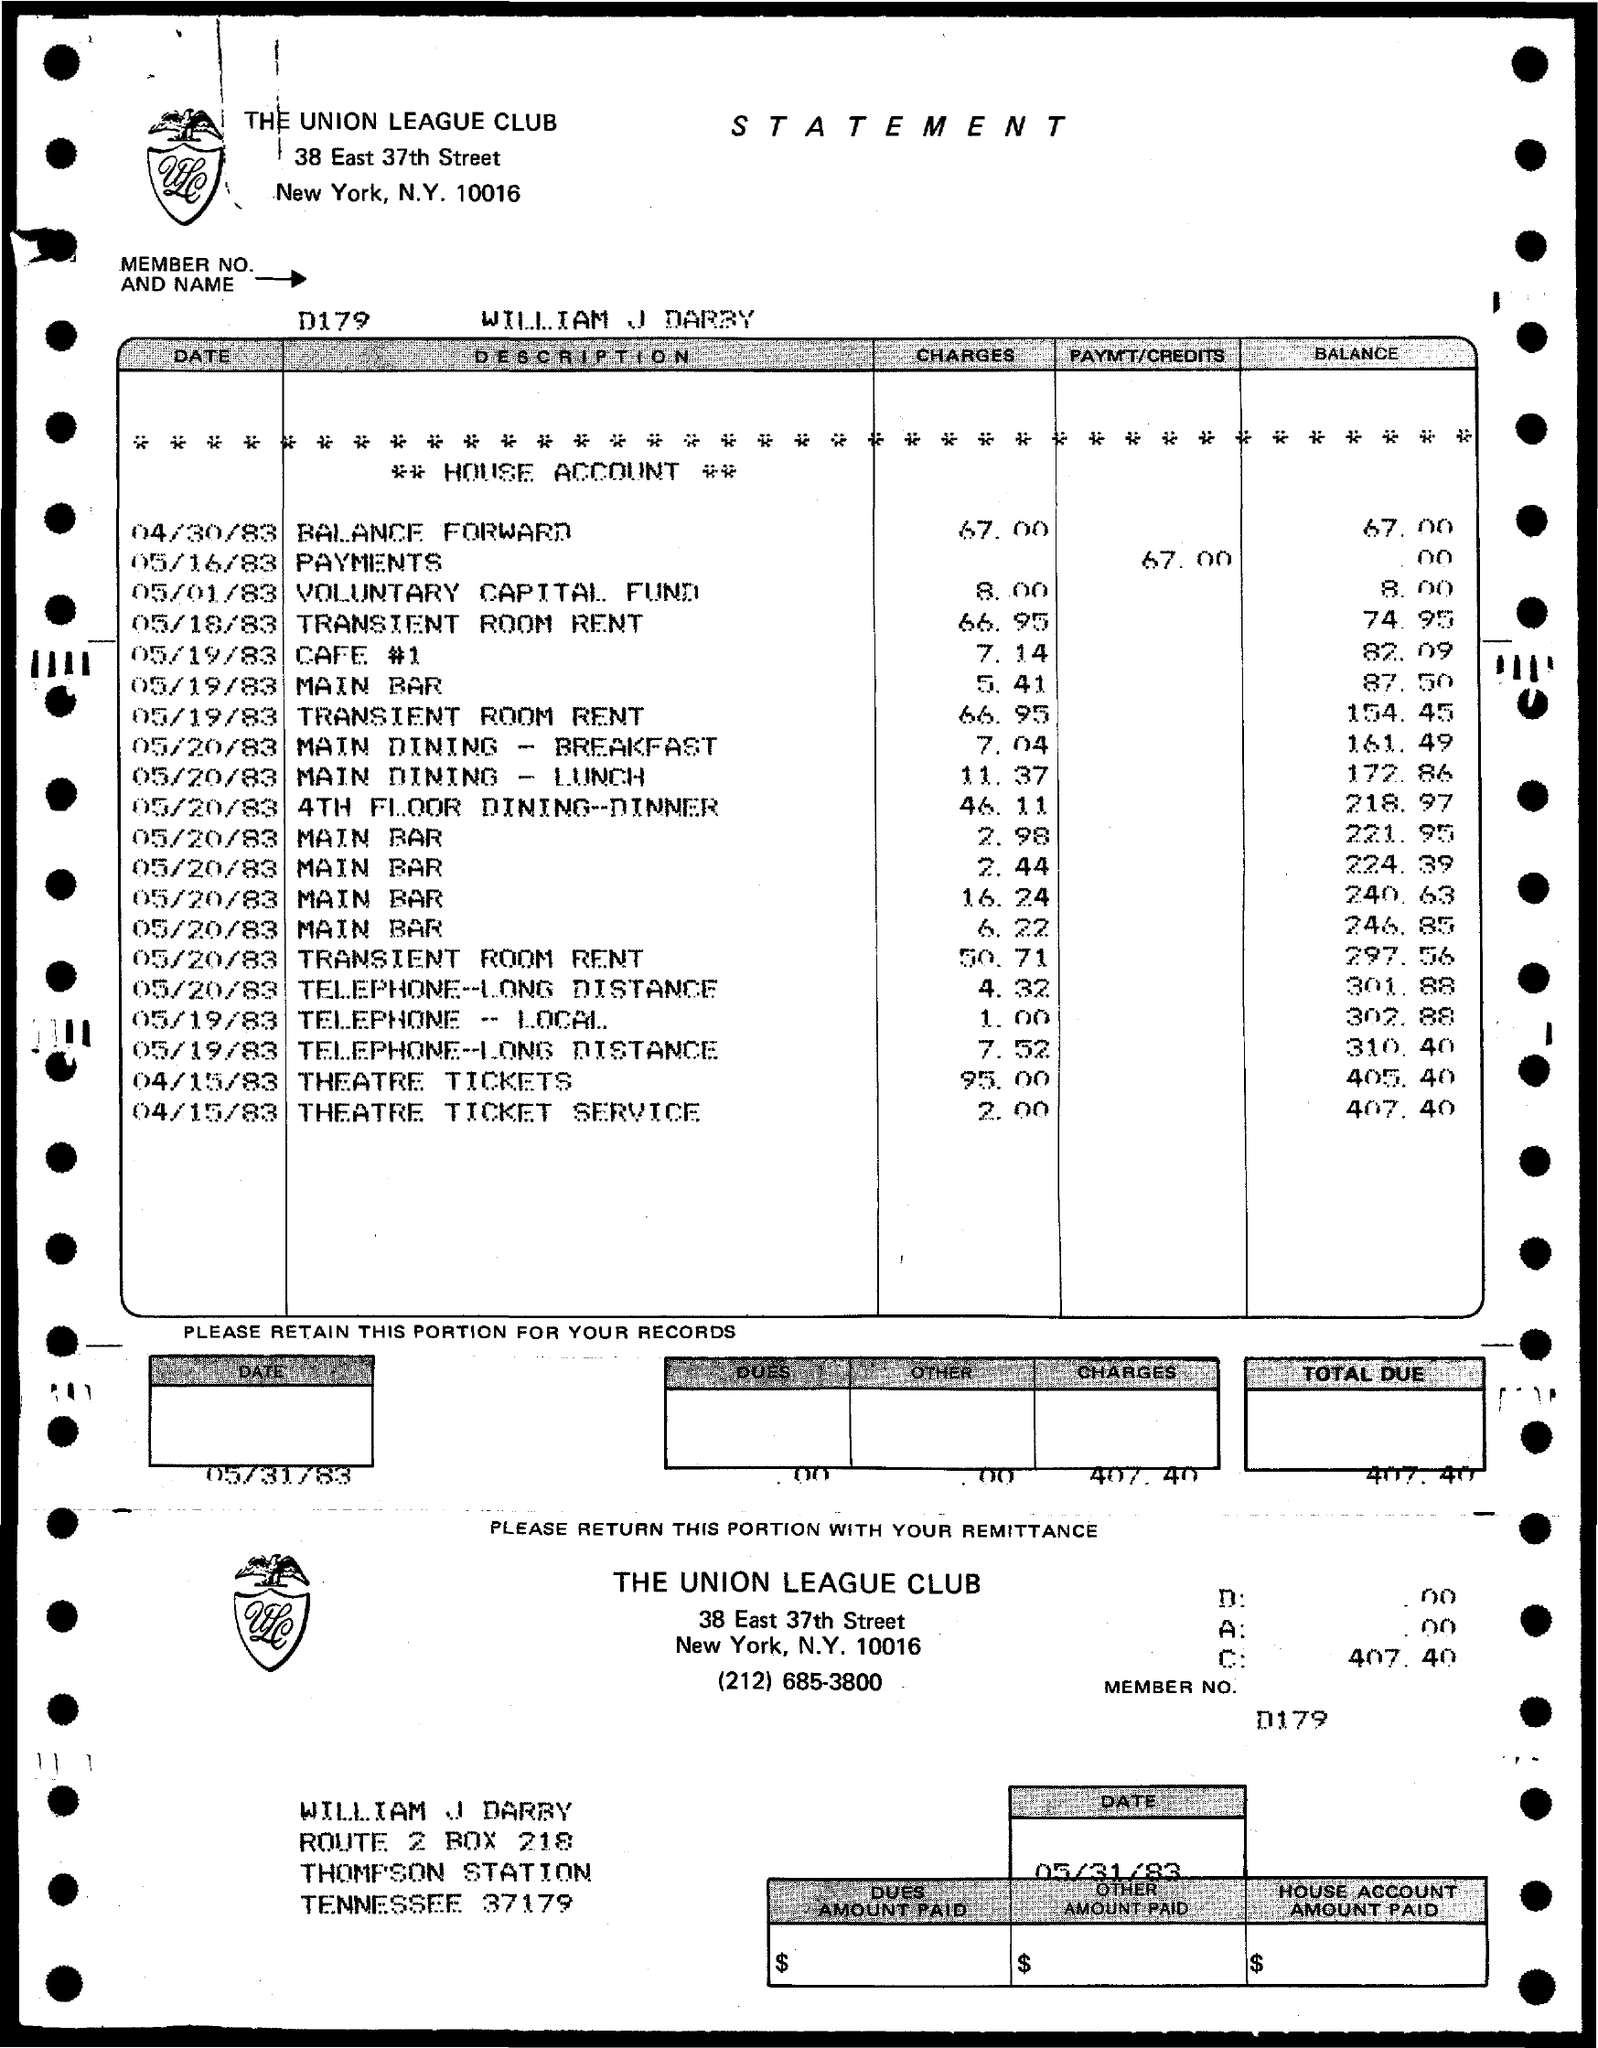Mention a couple of crucial points in this snapshot. I would like to know the member number. It is D179. The name of the member is William J Darby. 